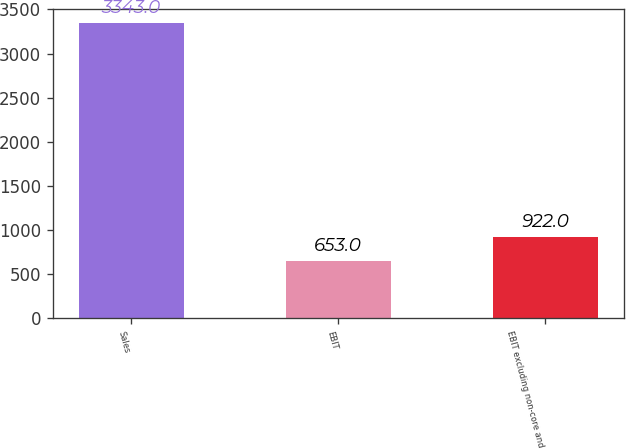Convert chart to OTSL. <chart><loc_0><loc_0><loc_500><loc_500><bar_chart><fcel>Sales<fcel>EBIT<fcel>EBIT excluding non-core and<nl><fcel>3343<fcel>653<fcel>922<nl></chart> 